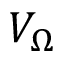<formula> <loc_0><loc_0><loc_500><loc_500>V _ { \Omega }</formula> 